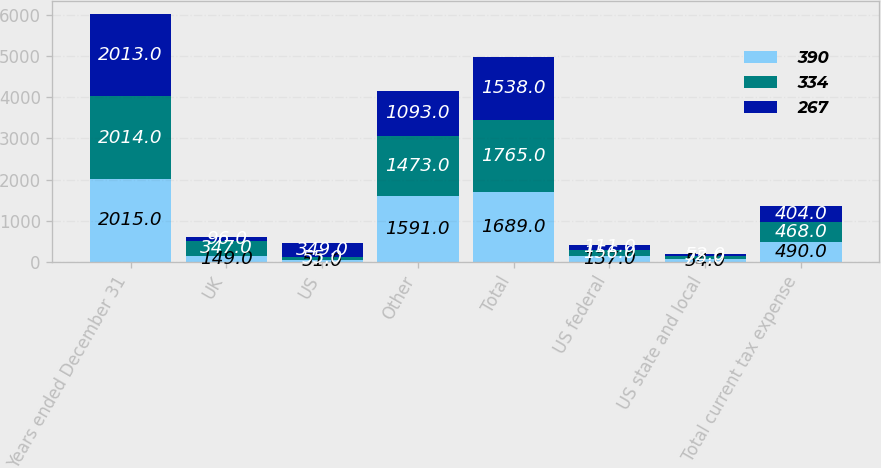<chart> <loc_0><loc_0><loc_500><loc_500><stacked_bar_chart><ecel><fcel>Years ended December 31<fcel>UK<fcel>US<fcel>Other<fcel>Total<fcel>US federal<fcel>US state and local<fcel>Total current tax expense<nl><fcel>390<fcel>2015<fcel>149<fcel>51<fcel>1591<fcel>1689<fcel>137<fcel>54<fcel>490<nl><fcel>334<fcel>2014<fcel>347<fcel>55<fcel>1473<fcel>1765<fcel>156<fcel>75<fcel>468<nl><fcel>267<fcel>2013<fcel>96<fcel>349<fcel>1093<fcel>1538<fcel>111<fcel>52<fcel>404<nl></chart> 